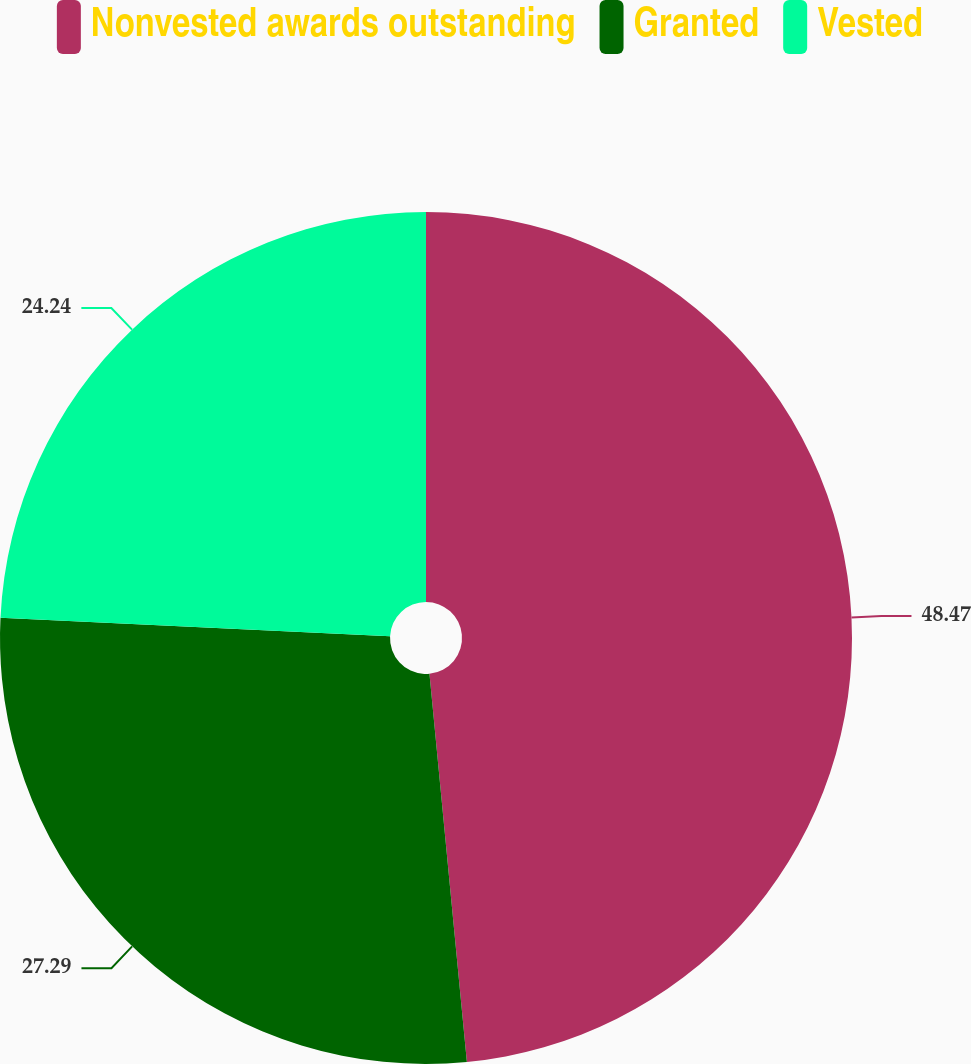<chart> <loc_0><loc_0><loc_500><loc_500><pie_chart><fcel>Nonvested awards outstanding<fcel>Granted<fcel>Vested<nl><fcel>48.47%<fcel>27.29%<fcel>24.24%<nl></chart> 